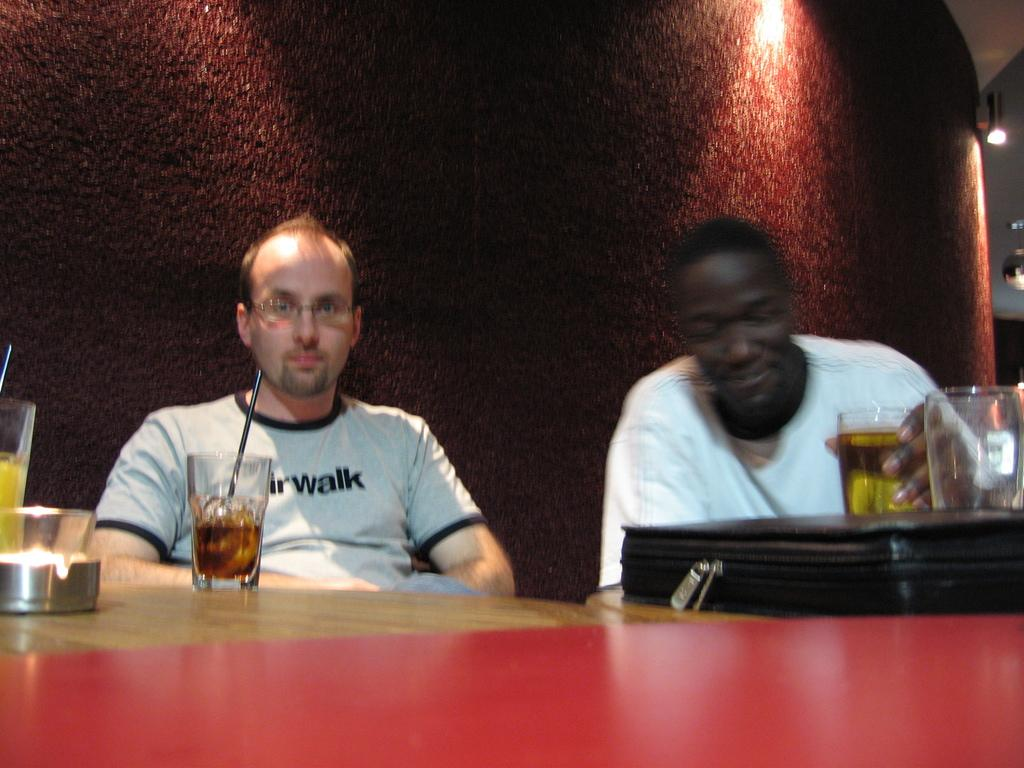How many people are in the image? There are two men in the image. What are the men doing in the image? The men are sitting. What objects can be seen on the table in the image? There are glasses and a bag on the table. What can be seen in the background of the image? There is a wall and a light in the background of the image. What type of toe is visible in the image? There are no toes visible in the image. What taste can be experienced from the light in the background? The light in the background does not have a taste, as it is not an edible object. 